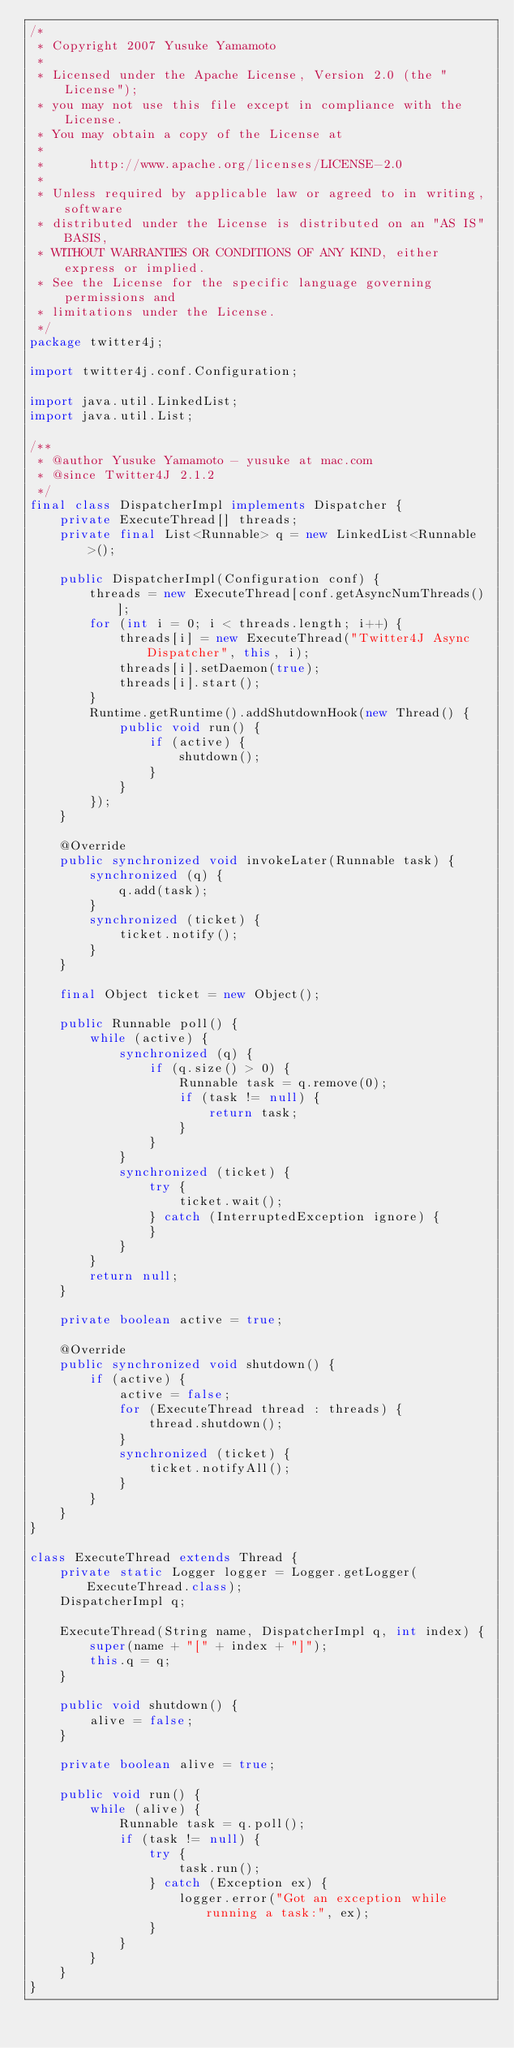Convert code to text. <code><loc_0><loc_0><loc_500><loc_500><_Java_>/*
 * Copyright 2007 Yusuke Yamamoto
 *
 * Licensed under the Apache License, Version 2.0 (the "License");
 * you may not use this file except in compliance with the License.
 * You may obtain a copy of the License at
 *
 *      http://www.apache.org/licenses/LICENSE-2.0
 *
 * Unless required by applicable law or agreed to in writing, software
 * distributed under the License is distributed on an "AS IS" BASIS,
 * WITHOUT WARRANTIES OR CONDITIONS OF ANY KIND, either express or implied.
 * See the License for the specific language governing permissions and
 * limitations under the License.
 */
package twitter4j;

import twitter4j.conf.Configuration;

import java.util.LinkedList;
import java.util.List;

/**
 * @author Yusuke Yamamoto - yusuke at mac.com
 * @since Twitter4J 2.1.2
 */
final class DispatcherImpl implements Dispatcher {
    private ExecuteThread[] threads;
    private final List<Runnable> q = new LinkedList<Runnable>();

    public DispatcherImpl(Configuration conf) {
        threads = new ExecuteThread[conf.getAsyncNumThreads()];
        for (int i = 0; i < threads.length; i++) {
            threads[i] = new ExecuteThread("Twitter4J Async Dispatcher", this, i);
            threads[i].setDaemon(true);
            threads[i].start();
        }
        Runtime.getRuntime().addShutdownHook(new Thread() {
            public void run() {
                if (active) {
                    shutdown();
                }
            }
        });
    }

    @Override
    public synchronized void invokeLater(Runnable task) {
        synchronized (q) {
            q.add(task);
        }
        synchronized (ticket) {
            ticket.notify();
        }
    }

    final Object ticket = new Object();

    public Runnable poll() {
        while (active) {
            synchronized (q) {
                if (q.size() > 0) {
                    Runnable task = q.remove(0);
                    if (task != null) {
                        return task;
                    }
                }
            }
            synchronized (ticket) {
                try {
                    ticket.wait();
                } catch (InterruptedException ignore) {
                }
            }
        }
        return null;
    }

    private boolean active = true;

    @Override
    public synchronized void shutdown() {
        if (active) {
            active = false;
            for (ExecuteThread thread : threads) {
                thread.shutdown();
            }
            synchronized (ticket) {
                ticket.notifyAll();
            }
        }
    }
}

class ExecuteThread extends Thread {
    private static Logger logger = Logger.getLogger(ExecuteThread.class);
    DispatcherImpl q;

    ExecuteThread(String name, DispatcherImpl q, int index) {
        super(name + "[" + index + "]");
        this.q = q;
    }

    public void shutdown() {
        alive = false;
    }

    private boolean alive = true;

    public void run() {
        while (alive) {
            Runnable task = q.poll();
            if (task != null) {
                try {
                    task.run();
                } catch (Exception ex) {
                    logger.error("Got an exception while running a task:", ex);
                }
            }
        }
    }
}
</code> 